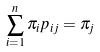Convert formula to latex. <formula><loc_0><loc_0><loc_500><loc_500>\sum _ { i = 1 } ^ { n } \pi _ { i } p _ { i j } = \pi _ { j }</formula> 